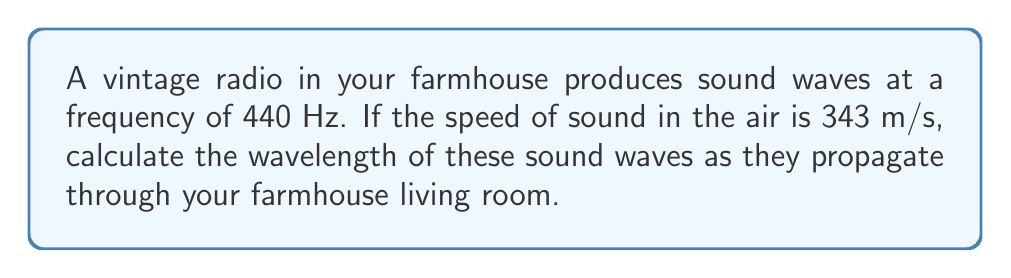Can you answer this question? Let's approach this step-by-step:

1) We know that for any wave, the relationship between wavelength ($\lambda$), frequency ($f$), and wave speed ($v$) is given by the equation:

   $$v = f \lambda$$

2) In this case, we're given:
   - Frequency, $f = 440$ Hz
   - Speed of sound in air, $v = 343$ m/s

3) We need to solve for wavelength, $\lambda$. Let's rearrange the equation:

   $$\lambda = \frac{v}{f}$$

4) Now, let's substitute our known values:

   $$\lambda = \frac{343 \text{ m/s}}{440 \text{ Hz}}$$

5) Simplify:

   $$\lambda = 0.77954545... \text{ m}$$

6) Rounding to two decimal places for practical purposes:

   $$\lambda \approx 0.78 \text{ m}$$

This means that as the sound waves from your vintage radio travel through your farmhouse living room, each complete wave cycle spans a distance of about 78 centimeters.
Answer: $0.78 \text{ m}$ 